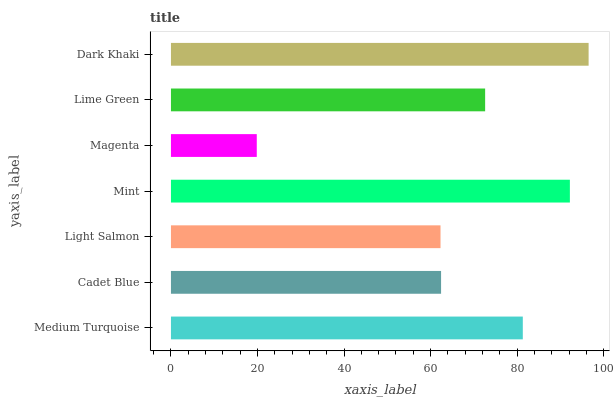Is Magenta the minimum?
Answer yes or no. Yes. Is Dark Khaki the maximum?
Answer yes or no. Yes. Is Cadet Blue the minimum?
Answer yes or no. No. Is Cadet Blue the maximum?
Answer yes or no. No. Is Medium Turquoise greater than Cadet Blue?
Answer yes or no. Yes. Is Cadet Blue less than Medium Turquoise?
Answer yes or no. Yes. Is Cadet Blue greater than Medium Turquoise?
Answer yes or no. No. Is Medium Turquoise less than Cadet Blue?
Answer yes or no. No. Is Lime Green the high median?
Answer yes or no. Yes. Is Lime Green the low median?
Answer yes or no. Yes. Is Medium Turquoise the high median?
Answer yes or no. No. Is Medium Turquoise the low median?
Answer yes or no. No. 